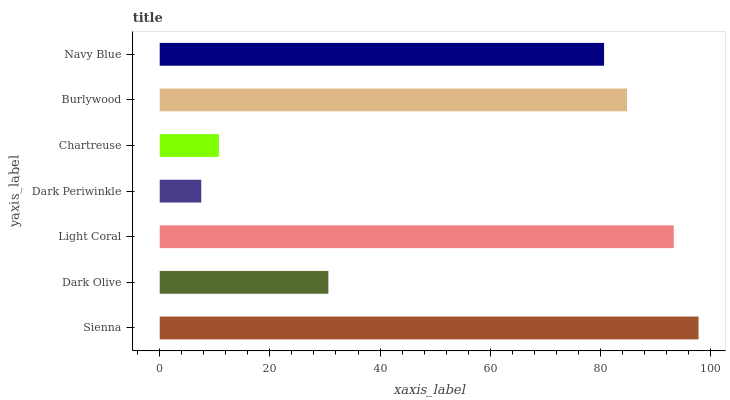Is Dark Periwinkle the minimum?
Answer yes or no. Yes. Is Sienna the maximum?
Answer yes or no. Yes. Is Dark Olive the minimum?
Answer yes or no. No. Is Dark Olive the maximum?
Answer yes or no. No. Is Sienna greater than Dark Olive?
Answer yes or no. Yes. Is Dark Olive less than Sienna?
Answer yes or no. Yes. Is Dark Olive greater than Sienna?
Answer yes or no. No. Is Sienna less than Dark Olive?
Answer yes or no. No. Is Navy Blue the high median?
Answer yes or no. Yes. Is Navy Blue the low median?
Answer yes or no. Yes. Is Dark Periwinkle the high median?
Answer yes or no. No. Is Dark Olive the low median?
Answer yes or no. No. 